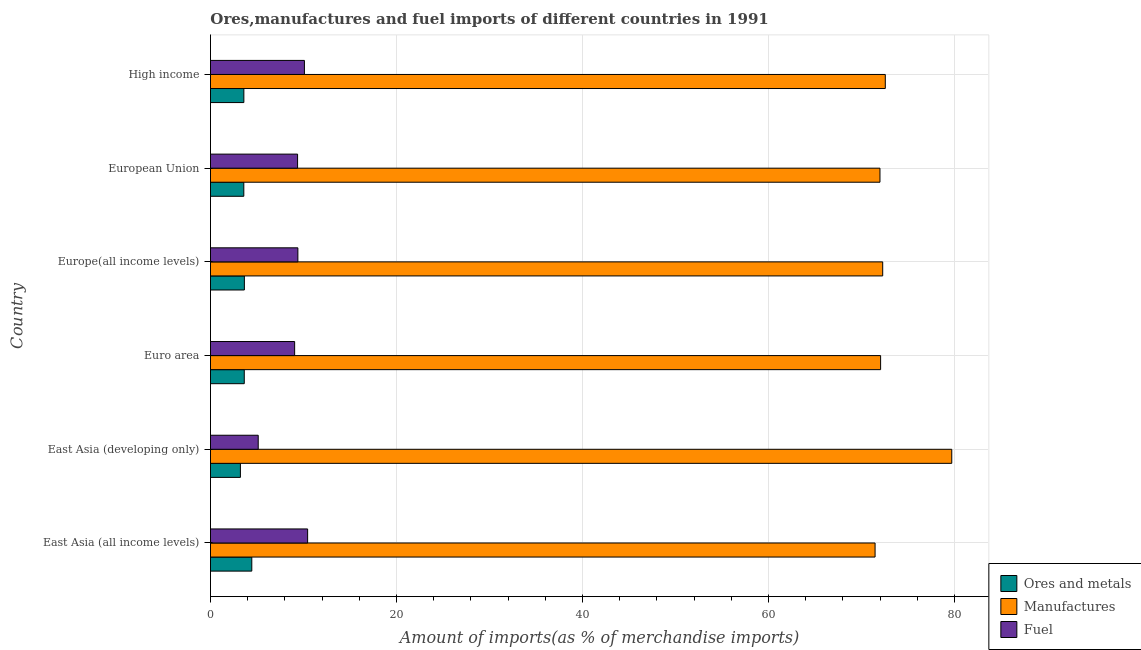How many groups of bars are there?
Your answer should be compact. 6. Are the number of bars per tick equal to the number of legend labels?
Provide a succinct answer. Yes. What is the label of the 1st group of bars from the top?
Give a very brief answer. High income. What is the percentage of manufactures imports in East Asia (developing only)?
Ensure brevity in your answer.  79.71. Across all countries, what is the maximum percentage of ores and metals imports?
Offer a very short reply. 4.44. Across all countries, what is the minimum percentage of fuel imports?
Your answer should be very brief. 5.13. In which country was the percentage of manufactures imports maximum?
Make the answer very short. East Asia (developing only). In which country was the percentage of fuel imports minimum?
Your answer should be very brief. East Asia (developing only). What is the total percentage of manufactures imports in the graph?
Provide a short and direct response. 440.08. What is the difference between the percentage of manufactures imports in Europe(all income levels) and that in High income?
Your response must be concise. -0.28. What is the difference between the percentage of manufactures imports in High income and the percentage of fuel imports in Europe(all income levels)?
Your response must be concise. 63.17. What is the average percentage of ores and metals imports per country?
Ensure brevity in your answer.  3.69. What is the difference between the percentage of ores and metals imports and percentage of manufactures imports in Euro area?
Offer a very short reply. -68.43. What is the ratio of the percentage of ores and metals imports in East Asia (all income levels) to that in Euro area?
Your answer should be compact. 1.22. Is the percentage of manufactures imports in Euro area less than that in European Union?
Offer a terse response. No. What is the difference between the highest and the second highest percentage of ores and metals imports?
Your answer should be compact. 0.8. What is the difference between the highest and the lowest percentage of fuel imports?
Keep it short and to the point. 5.31. In how many countries, is the percentage of ores and metals imports greater than the average percentage of ores and metals imports taken over all countries?
Give a very brief answer. 1. What does the 3rd bar from the top in Euro area represents?
Give a very brief answer. Ores and metals. What does the 2nd bar from the bottom in East Asia (all income levels) represents?
Keep it short and to the point. Manufactures. Is it the case that in every country, the sum of the percentage of ores and metals imports and percentage of manufactures imports is greater than the percentage of fuel imports?
Provide a succinct answer. Yes. How many bars are there?
Make the answer very short. 18. Are all the bars in the graph horizontal?
Provide a short and direct response. Yes. How many countries are there in the graph?
Provide a succinct answer. 6. What is the difference between two consecutive major ticks on the X-axis?
Offer a very short reply. 20. Does the graph contain any zero values?
Give a very brief answer. No. Does the graph contain grids?
Provide a succinct answer. Yes. Where does the legend appear in the graph?
Provide a succinct answer. Bottom right. How are the legend labels stacked?
Offer a very short reply. Vertical. What is the title of the graph?
Your answer should be compact. Ores,manufactures and fuel imports of different countries in 1991. Does "Services" appear as one of the legend labels in the graph?
Make the answer very short. No. What is the label or title of the X-axis?
Your response must be concise. Amount of imports(as % of merchandise imports). What is the label or title of the Y-axis?
Offer a very short reply. Country. What is the Amount of imports(as % of merchandise imports) of Ores and metals in East Asia (all income levels)?
Offer a terse response. 4.44. What is the Amount of imports(as % of merchandise imports) of Manufactures in East Asia (all income levels)?
Provide a short and direct response. 71.47. What is the Amount of imports(as % of merchandise imports) in Fuel in East Asia (all income levels)?
Give a very brief answer. 10.45. What is the Amount of imports(as % of merchandise imports) of Ores and metals in East Asia (developing only)?
Make the answer very short. 3.22. What is the Amount of imports(as % of merchandise imports) in Manufactures in East Asia (developing only)?
Offer a terse response. 79.71. What is the Amount of imports(as % of merchandise imports) in Fuel in East Asia (developing only)?
Make the answer very short. 5.13. What is the Amount of imports(as % of merchandise imports) of Ores and metals in Euro area?
Your answer should be compact. 3.63. What is the Amount of imports(as % of merchandise imports) of Manufactures in Euro area?
Offer a very short reply. 72.06. What is the Amount of imports(as % of merchandise imports) of Fuel in Euro area?
Your response must be concise. 9.05. What is the Amount of imports(as % of merchandise imports) of Ores and metals in Europe(all income levels)?
Give a very brief answer. 3.64. What is the Amount of imports(as % of merchandise imports) in Manufactures in Europe(all income levels)?
Keep it short and to the point. 72.29. What is the Amount of imports(as % of merchandise imports) in Fuel in Europe(all income levels)?
Your answer should be compact. 9.4. What is the Amount of imports(as % of merchandise imports) of Ores and metals in European Union?
Keep it short and to the point. 3.58. What is the Amount of imports(as % of merchandise imports) in Manufactures in European Union?
Ensure brevity in your answer.  71.99. What is the Amount of imports(as % of merchandise imports) in Fuel in European Union?
Your answer should be compact. 9.37. What is the Amount of imports(as % of merchandise imports) in Ores and metals in High income?
Ensure brevity in your answer.  3.59. What is the Amount of imports(as % of merchandise imports) in Manufactures in High income?
Offer a very short reply. 72.57. What is the Amount of imports(as % of merchandise imports) of Fuel in High income?
Ensure brevity in your answer.  10.1. Across all countries, what is the maximum Amount of imports(as % of merchandise imports) in Ores and metals?
Provide a succinct answer. 4.44. Across all countries, what is the maximum Amount of imports(as % of merchandise imports) in Manufactures?
Provide a short and direct response. 79.71. Across all countries, what is the maximum Amount of imports(as % of merchandise imports) of Fuel?
Keep it short and to the point. 10.45. Across all countries, what is the minimum Amount of imports(as % of merchandise imports) of Ores and metals?
Your answer should be very brief. 3.22. Across all countries, what is the minimum Amount of imports(as % of merchandise imports) of Manufactures?
Give a very brief answer. 71.47. Across all countries, what is the minimum Amount of imports(as % of merchandise imports) in Fuel?
Provide a short and direct response. 5.13. What is the total Amount of imports(as % of merchandise imports) in Ores and metals in the graph?
Your answer should be compact. 22.11. What is the total Amount of imports(as % of merchandise imports) in Manufactures in the graph?
Ensure brevity in your answer.  440.08. What is the total Amount of imports(as % of merchandise imports) in Fuel in the graph?
Your answer should be compact. 53.5. What is the difference between the Amount of imports(as % of merchandise imports) in Ores and metals in East Asia (all income levels) and that in East Asia (developing only)?
Give a very brief answer. 1.22. What is the difference between the Amount of imports(as % of merchandise imports) in Manufactures in East Asia (all income levels) and that in East Asia (developing only)?
Your answer should be very brief. -8.25. What is the difference between the Amount of imports(as % of merchandise imports) in Fuel in East Asia (all income levels) and that in East Asia (developing only)?
Ensure brevity in your answer.  5.31. What is the difference between the Amount of imports(as % of merchandise imports) of Ores and metals in East Asia (all income levels) and that in Euro area?
Make the answer very short. 0.81. What is the difference between the Amount of imports(as % of merchandise imports) in Manufactures in East Asia (all income levels) and that in Euro area?
Offer a very short reply. -0.59. What is the difference between the Amount of imports(as % of merchandise imports) in Fuel in East Asia (all income levels) and that in Euro area?
Ensure brevity in your answer.  1.4. What is the difference between the Amount of imports(as % of merchandise imports) of Ores and metals in East Asia (all income levels) and that in Europe(all income levels)?
Make the answer very short. 0.8. What is the difference between the Amount of imports(as % of merchandise imports) in Manufactures in East Asia (all income levels) and that in Europe(all income levels)?
Your answer should be very brief. -0.82. What is the difference between the Amount of imports(as % of merchandise imports) of Fuel in East Asia (all income levels) and that in Europe(all income levels)?
Provide a succinct answer. 1.05. What is the difference between the Amount of imports(as % of merchandise imports) in Ores and metals in East Asia (all income levels) and that in European Union?
Give a very brief answer. 0.86. What is the difference between the Amount of imports(as % of merchandise imports) of Manufactures in East Asia (all income levels) and that in European Union?
Provide a succinct answer. -0.52. What is the difference between the Amount of imports(as % of merchandise imports) of Fuel in East Asia (all income levels) and that in European Union?
Your response must be concise. 1.08. What is the difference between the Amount of imports(as % of merchandise imports) in Ores and metals in East Asia (all income levels) and that in High income?
Give a very brief answer. 0.85. What is the difference between the Amount of imports(as % of merchandise imports) in Manufactures in East Asia (all income levels) and that in High income?
Your answer should be very brief. -1.1. What is the difference between the Amount of imports(as % of merchandise imports) in Fuel in East Asia (all income levels) and that in High income?
Your response must be concise. 0.34. What is the difference between the Amount of imports(as % of merchandise imports) in Ores and metals in East Asia (developing only) and that in Euro area?
Offer a terse response. -0.41. What is the difference between the Amount of imports(as % of merchandise imports) in Manufactures in East Asia (developing only) and that in Euro area?
Provide a succinct answer. 7.65. What is the difference between the Amount of imports(as % of merchandise imports) of Fuel in East Asia (developing only) and that in Euro area?
Make the answer very short. -3.92. What is the difference between the Amount of imports(as % of merchandise imports) in Ores and metals in East Asia (developing only) and that in Europe(all income levels)?
Your answer should be very brief. -0.43. What is the difference between the Amount of imports(as % of merchandise imports) of Manufactures in East Asia (developing only) and that in Europe(all income levels)?
Keep it short and to the point. 7.43. What is the difference between the Amount of imports(as % of merchandise imports) in Fuel in East Asia (developing only) and that in Europe(all income levels)?
Your answer should be very brief. -4.26. What is the difference between the Amount of imports(as % of merchandise imports) in Ores and metals in East Asia (developing only) and that in European Union?
Your answer should be very brief. -0.37. What is the difference between the Amount of imports(as % of merchandise imports) in Manufactures in East Asia (developing only) and that in European Union?
Provide a short and direct response. 7.72. What is the difference between the Amount of imports(as % of merchandise imports) in Fuel in East Asia (developing only) and that in European Union?
Offer a very short reply. -4.23. What is the difference between the Amount of imports(as % of merchandise imports) of Ores and metals in East Asia (developing only) and that in High income?
Offer a terse response. -0.37. What is the difference between the Amount of imports(as % of merchandise imports) of Manufactures in East Asia (developing only) and that in High income?
Ensure brevity in your answer.  7.15. What is the difference between the Amount of imports(as % of merchandise imports) in Fuel in East Asia (developing only) and that in High income?
Keep it short and to the point. -4.97. What is the difference between the Amount of imports(as % of merchandise imports) in Ores and metals in Euro area and that in Europe(all income levels)?
Ensure brevity in your answer.  -0.01. What is the difference between the Amount of imports(as % of merchandise imports) of Manufactures in Euro area and that in Europe(all income levels)?
Keep it short and to the point. -0.22. What is the difference between the Amount of imports(as % of merchandise imports) of Fuel in Euro area and that in Europe(all income levels)?
Ensure brevity in your answer.  -0.35. What is the difference between the Amount of imports(as % of merchandise imports) of Ores and metals in Euro area and that in European Union?
Your response must be concise. 0.05. What is the difference between the Amount of imports(as % of merchandise imports) in Manufactures in Euro area and that in European Union?
Your response must be concise. 0.07. What is the difference between the Amount of imports(as % of merchandise imports) of Fuel in Euro area and that in European Union?
Your answer should be compact. -0.32. What is the difference between the Amount of imports(as % of merchandise imports) of Ores and metals in Euro area and that in High income?
Ensure brevity in your answer.  0.04. What is the difference between the Amount of imports(as % of merchandise imports) of Manufactures in Euro area and that in High income?
Offer a very short reply. -0.5. What is the difference between the Amount of imports(as % of merchandise imports) in Fuel in Euro area and that in High income?
Make the answer very short. -1.05. What is the difference between the Amount of imports(as % of merchandise imports) in Ores and metals in Europe(all income levels) and that in European Union?
Ensure brevity in your answer.  0.06. What is the difference between the Amount of imports(as % of merchandise imports) in Manufactures in Europe(all income levels) and that in European Union?
Ensure brevity in your answer.  0.29. What is the difference between the Amount of imports(as % of merchandise imports) of Fuel in Europe(all income levels) and that in European Union?
Give a very brief answer. 0.03. What is the difference between the Amount of imports(as % of merchandise imports) of Ores and metals in Europe(all income levels) and that in High income?
Your answer should be compact. 0.06. What is the difference between the Amount of imports(as % of merchandise imports) in Manufactures in Europe(all income levels) and that in High income?
Provide a short and direct response. -0.28. What is the difference between the Amount of imports(as % of merchandise imports) of Fuel in Europe(all income levels) and that in High income?
Ensure brevity in your answer.  -0.7. What is the difference between the Amount of imports(as % of merchandise imports) of Ores and metals in European Union and that in High income?
Keep it short and to the point. -0.01. What is the difference between the Amount of imports(as % of merchandise imports) in Manufactures in European Union and that in High income?
Provide a succinct answer. -0.57. What is the difference between the Amount of imports(as % of merchandise imports) of Fuel in European Union and that in High income?
Provide a succinct answer. -0.74. What is the difference between the Amount of imports(as % of merchandise imports) of Ores and metals in East Asia (all income levels) and the Amount of imports(as % of merchandise imports) of Manufactures in East Asia (developing only)?
Ensure brevity in your answer.  -75.27. What is the difference between the Amount of imports(as % of merchandise imports) of Ores and metals in East Asia (all income levels) and the Amount of imports(as % of merchandise imports) of Fuel in East Asia (developing only)?
Ensure brevity in your answer.  -0.69. What is the difference between the Amount of imports(as % of merchandise imports) in Manufactures in East Asia (all income levels) and the Amount of imports(as % of merchandise imports) in Fuel in East Asia (developing only)?
Provide a short and direct response. 66.33. What is the difference between the Amount of imports(as % of merchandise imports) of Ores and metals in East Asia (all income levels) and the Amount of imports(as % of merchandise imports) of Manufactures in Euro area?
Offer a very short reply. -67.62. What is the difference between the Amount of imports(as % of merchandise imports) in Ores and metals in East Asia (all income levels) and the Amount of imports(as % of merchandise imports) in Fuel in Euro area?
Provide a short and direct response. -4.61. What is the difference between the Amount of imports(as % of merchandise imports) in Manufactures in East Asia (all income levels) and the Amount of imports(as % of merchandise imports) in Fuel in Euro area?
Your answer should be very brief. 62.42. What is the difference between the Amount of imports(as % of merchandise imports) of Ores and metals in East Asia (all income levels) and the Amount of imports(as % of merchandise imports) of Manufactures in Europe(all income levels)?
Provide a short and direct response. -67.84. What is the difference between the Amount of imports(as % of merchandise imports) of Ores and metals in East Asia (all income levels) and the Amount of imports(as % of merchandise imports) of Fuel in Europe(all income levels)?
Provide a short and direct response. -4.96. What is the difference between the Amount of imports(as % of merchandise imports) in Manufactures in East Asia (all income levels) and the Amount of imports(as % of merchandise imports) in Fuel in Europe(all income levels)?
Offer a terse response. 62.07. What is the difference between the Amount of imports(as % of merchandise imports) in Ores and metals in East Asia (all income levels) and the Amount of imports(as % of merchandise imports) in Manufactures in European Union?
Provide a short and direct response. -67.55. What is the difference between the Amount of imports(as % of merchandise imports) in Ores and metals in East Asia (all income levels) and the Amount of imports(as % of merchandise imports) in Fuel in European Union?
Your answer should be compact. -4.92. What is the difference between the Amount of imports(as % of merchandise imports) in Manufactures in East Asia (all income levels) and the Amount of imports(as % of merchandise imports) in Fuel in European Union?
Your response must be concise. 62.1. What is the difference between the Amount of imports(as % of merchandise imports) of Ores and metals in East Asia (all income levels) and the Amount of imports(as % of merchandise imports) of Manufactures in High income?
Make the answer very short. -68.12. What is the difference between the Amount of imports(as % of merchandise imports) of Ores and metals in East Asia (all income levels) and the Amount of imports(as % of merchandise imports) of Fuel in High income?
Keep it short and to the point. -5.66. What is the difference between the Amount of imports(as % of merchandise imports) of Manufactures in East Asia (all income levels) and the Amount of imports(as % of merchandise imports) of Fuel in High income?
Provide a succinct answer. 61.36. What is the difference between the Amount of imports(as % of merchandise imports) in Ores and metals in East Asia (developing only) and the Amount of imports(as % of merchandise imports) in Manufactures in Euro area?
Ensure brevity in your answer.  -68.84. What is the difference between the Amount of imports(as % of merchandise imports) in Ores and metals in East Asia (developing only) and the Amount of imports(as % of merchandise imports) in Fuel in Euro area?
Ensure brevity in your answer.  -5.83. What is the difference between the Amount of imports(as % of merchandise imports) in Manufactures in East Asia (developing only) and the Amount of imports(as % of merchandise imports) in Fuel in Euro area?
Keep it short and to the point. 70.66. What is the difference between the Amount of imports(as % of merchandise imports) of Ores and metals in East Asia (developing only) and the Amount of imports(as % of merchandise imports) of Manufactures in Europe(all income levels)?
Keep it short and to the point. -69.07. What is the difference between the Amount of imports(as % of merchandise imports) in Ores and metals in East Asia (developing only) and the Amount of imports(as % of merchandise imports) in Fuel in Europe(all income levels)?
Provide a short and direct response. -6.18. What is the difference between the Amount of imports(as % of merchandise imports) of Manufactures in East Asia (developing only) and the Amount of imports(as % of merchandise imports) of Fuel in Europe(all income levels)?
Keep it short and to the point. 70.31. What is the difference between the Amount of imports(as % of merchandise imports) of Ores and metals in East Asia (developing only) and the Amount of imports(as % of merchandise imports) of Manufactures in European Union?
Offer a very short reply. -68.77. What is the difference between the Amount of imports(as % of merchandise imports) of Ores and metals in East Asia (developing only) and the Amount of imports(as % of merchandise imports) of Fuel in European Union?
Provide a succinct answer. -6.15. What is the difference between the Amount of imports(as % of merchandise imports) in Manufactures in East Asia (developing only) and the Amount of imports(as % of merchandise imports) in Fuel in European Union?
Ensure brevity in your answer.  70.35. What is the difference between the Amount of imports(as % of merchandise imports) of Ores and metals in East Asia (developing only) and the Amount of imports(as % of merchandise imports) of Manufactures in High income?
Your answer should be very brief. -69.35. What is the difference between the Amount of imports(as % of merchandise imports) of Ores and metals in East Asia (developing only) and the Amount of imports(as % of merchandise imports) of Fuel in High income?
Your answer should be very brief. -6.88. What is the difference between the Amount of imports(as % of merchandise imports) in Manufactures in East Asia (developing only) and the Amount of imports(as % of merchandise imports) in Fuel in High income?
Make the answer very short. 69.61. What is the difference between the Amount of imports(as % of merchandise imports) of Ores and metals in Euro area and the Amount of imports(as % of merchandise imports) of Manufactures in Europe(all income levels)?
Make the answer very short. -68.65. What is the difference between the Amount of imports(as % of merchandise imports) in Ores and metals in Euro area and the Amount of imports(as % of merchandise imports) in Fuel in Europe(all income levels)?
Provide a short and direct response. -5.77. What is the difference between the Amount of imports(as % of merchandise imports) of Manufactures in Euro area and the Amount of imports(as % of merchandise imports) of Fuel in Europe(all income levels)?
Your answer should be very brief. 62.66. What is the difference between the Amount of imports(as % of merchandise imports) in Ores and metals in Euro area and the Amount of imports(as % of merchandise imports) in Manufactures in European Union?
Keep it short and to the point. -68.36. What is the difference between the Amount of imports(as % of merchandise imports) in Ores and metals in Euro area and the Amount of imports(as % of merchandise imports) in Fuel in European Union?
Make the answer very short. -5.73. What is the difference between the Amount of imports(as % of merchandise imports) of Manufactures in Euro area and the Amount of imports(as % of merchandise imports) of Fuel in European Union?
Give a very brief answer. 62.69. What is the difference between the Amount of imports(as % of merchandise imports) of Ores and metals in Euro area and the Amount of imports(as % of merchandise imports) of Manufactures in High income?
Offer a very short reply. -68.93. What is the difference between the Amount of imports(as % of merchandise imports) of Ores and metals in Euro area and the Amount of imports(as % of merchandise imports) of Fuel in High income?
Keep it short and to the point. -6.47. What is the difference between the Amount of imports(as % of merchandise imports) in Manufactures in Euro area and the Amount of imports(as % of merchandise imports) in Fuel in High income?
Offer a terse response. 61.96. What is the difference between the Amount of imports(as % of merchandise imports) of Ores and metals in Europe(all income levels) and the Amount of imports(as % of merchandise imports) of Manufactures in European Union?
Your response must be concise. -68.35. What is the difference between the Amount of imports(as % of merchandise imports) of Ores and metals in Europe(all income levels) and the Amount of imports(as % of merchandise imports) of Fuel in European Union?
Offer a very short reply. -5.72. What is the difference between the Amount of imports(as % of merchandise imports) in Manufactures in Europe(all income levels) and the Amount of imports(as % of merchandise imports) in Fuel in European Union?
Your answer should be very brief. 62.92. What is the difference between the Amount of imports(as % of merchandise imports) in Ores and metals in Europe(all income levels) and the Amount of imports(as % of merchandise imports) in Manufactures in High income?
Provide a succinct answer. -68.92. What is the difference between the Amount of imports(as % of merchandise imports) of Ores and metals in Europe(all income levels) and the Amount of imports(as % of merchandise imports) of Fuel in High income?
Keep it short and to the point. -6.46. What is the difference between the Amount of imports(as % of merchandise imports) of Manufactures in Europe(all income levels) and the Amount of imports(as % of merchandise imports) of Fuel in High income?
Offer a very short reply. 62.18. What is the difference between the Amount of imports(as % of merchandise imports) in Ores and metals in European Union and the Amount of imports(as % of merchandise imports) in Manufactures in High income?
Give a very brief answer. -68.98. What is the difference between the Amount of imports(as % of merchandise imports) in Ores and metals in European Union and the Amount of imports(as % of merchandise imports) in Fuel in High income?
Offer a terse response. -6.52. What is the difference between the Amount of imports(as % of merchandise imports) of Manufactures in European Union and the Amount of imports(as % of merchandise imports) of Fuel in High income?
Provide a short and direct response. 61.89. What is the average Amount of imports(as % of merchandise imports) of Ores and metals per country?
Give a very brief answer. 3.69. What is the average Amount of imports(as % of merchandise imports) in Manufactures per country?
Ensure brevity in your answer.  73.35. What is the average Amount of imports(as % of merchandise imports) in Fuel per country?
Keep it short and to the point. 8.92. What is the difference between the Amount of imports(as % of merchandise imports) of Ores and metals and Amount of imports(as % of merchandise imports) of Manufactures in East Asia (all income levels)?
Offer a very short reply. -67.02. What is the difference between the Amount of imports(as % of merchandise imports) in Ores and metals and Amount of imports(as % of merchandise imports) in Fuel in East Asia (all income levels)?
Make the answer very short. -6. What is the difference between the Amount of imports(as % of merchandise imports) in Manufactures and Amount of imports(as % of merchandise imports) in Fuel in East Asia (all income levels)?
Provide a short and direct response. 61.02. What is the difference between the Amount of imports(as % of merchandise imports) in Ores and metals and Amount of imports(as % of merchandise imports) in Manufactures in East Asia (developing only)?
Your answer should be very brief. -76.49. What is the difference between the Amount of imports(as % of merchandise imports) of Ores and metals and Amount of imports(as % of merchandise imports) of Fuel in East Asia (developing only)?
Your answer should be very brief. -1.92. What is the difference between the Amount of imports(as % of merchandise imports) in Manufactures and Amount of imports(as % of merchandise imports) in Fuel in East Asia (developing only)?
Offer a terse response. 74.58. What is the difference between the Amount of imports(as % of merchandise imports) in Ores and metals and Amount of imports(as % of merchandise imports) in Manufactures in Euro area?
Make the answer very short. -68.43. What is the difference between the Amount of imports(as % of merchandise imports) in Ores and metals and Amount of imports(as % of merchandise imports) in Fuel in Euro area?
Your answer should be compact. -5.42. What is the difference between the Amount of imports(as % of merchandise imports) of Manufactures and Amount of imports(as % of merchandise imports) of Fuel in Euro area?
Offer a very short reply. 63.01. What is the difference between the Amount of imports(as % of merchandise imports) in Ores and metals and Amount of imports(as % of merchandise imports) in Manufactures in Europe(all income levels)?
Your response must be concise. -68.64. What is the difference between the Amount of imports(as % of merchandise imports) of Ores and metals and Amount of imports(as % of merchandise imports) of Fuel in Europe(all income levels)?
Provide a short and direct response. -5.75. What is the difference between the Amount of imports(as % of merchandise imports) of Manufactures and Amount of imports(as % of merchandise imports) of Fuel in Europe(all income levels)?
Keep it short and to the point. 62.89. What is the difference between the Amount of imports(as % of merchandise imports) in Ores and metals and Amount of imports(as % of merchandise imports) in Manufactures in European Union?
Provide a short and direct response. -68.41. What is the difference between the Amount of imports(as % of merchandise imports) in Ores and metals and Amount of imports(as % of merchandise imports) in Fuel in European Union?
Offer a very short reply. -5.78. What is the difference between the Amount of imports(as % of merchandise imports) of Manufactures and Amount of imports(as % of merchandise imports) of Fuel in European Union?
Offer a very short reply. 62.62. What is the difference between the Amount of imports(as % of merchandise imports) of Ores and metals and Amount of imports(as % of merchandise imports) of Manufactures in High income?
Your answer should be very brief. -68.98. What is the difference between the Amount of imports(as % of merchandise imports) in Ores and metals and Amount of imports(as % of merchandise imports) in Fuel in High income?
Keep it short and to the point. -6.51. What is the difference between the Amount of imports(as % of merchandise imports) in Manufactures and Amount of imports(as % of merchandise imports) in Fuel in High income?
Offer a terse response. 62.46. What is the ratio of the Amount of imports(as % of merchandise imports) of Ores and metals in East Asia (all income levels) to that in East Asia (developing only)?
Your answer should be very brief. 1.38. What is the ratio of the Amount of imports(as % of merchandise imports) of Manufactures in East Asia (all income levels) to that in East Asia (developing only)?
Give a very brief answer. 0.9. What is the ratio of the Amount of imports(as % of merchandise imports) in Fuel in East Asia (all income levels) to that in East Asia (developing only)?
Offer a terse response. 2.03. What is the ratio of the Amount of imports(as % of merchandise imports) in Ores and metals in East Asia (all income levels) to that in Euro area?
Give a very brief answer. 1.22. What is the ratio of the Amount of imports(as % of merchandise imports) in Manufactures in East Asia (all income levels) to that in Euro area?
Give a very brief answer. 0.99. What is the ratio of the Amount of imports(as % of merchandise imports) in Fuel in East Asia (all income levels) to that in Euro area?
Offer a terse response. 1.15. What is the ratio of the Amount of imports(as % of merchandise imports) in Ores and metals in East Asia (all income levels) to that in Europe(all income levels)?
Your response must be concise. 1.22. What is the ratio of the Amount of imports(as % of merchandise imports) of Manufactures in East Asia (all income levels) to that in Europe(all income levels)?
Your answer should be compact. 0.99. What is the ratio of the Amount of imports(as % of merchandise imports) in Fuel in East Asia (all income levels) to that in Europe(all income levels)?
Offer a very short reply. 1.11. What is the ratio of the Amount of imports(as % of merchandise imports) in Ores and metals in East Asia (all income levels) to that in European Union?
Your answer should be compact. 1.24. What is the ratio of the Amount of imports(as % of merchandise imports) of Manufactures in East Asia (all income levels) to that in European Union?
Ensure brevity in your answer.  0.99. What is the ratio of the Amount of imports(as % of merchandise imports) of Fuel in East Asia (all income levels) to that in European Union?
Your answer should be very brief. 1.12. What is the ratio of the Amount of imports(as % of merchandise imports) in Ores and metals in East Asia (all income levels) to that in High income?
Offer a terse response. 1.24. What is the ratio of the Amount of imports(as % of merchandise imports) in Manufactures in East Asia (all income levels) to that in High income?
Your answer should be very brief. 0.98. What is the ratio of the Amount of imports(as % of merchandise imports) of Fuel in East Asia (all income levels) to that in High income?
Make the answer very short. 1.03. What is the ratio of the Amount of imports(as % of merchandise imports) of Ores and metals in East Asia (developing only) to that in Euro area?
Provide a short and direct response. 0.89. What is the ratio of the Amount of imports(as % of merchandise imports) in Manufactures in East Asia (developing only) to that in Euro area?
Ensure brevity in your answer.  1.11. What is the ratio of the Amount of imports(as % of merchandise imports) in Fuel in East Asia (developing only) to that in Euro area?
Provide a short and direct response. 0.57. What is the ratio of the Amount of imports(as % of merchandise imports) of Ores and metals in East Asia (developing only) to that in Europe(all income levels)?
Your answer should be very brief. 0.88. What is the ratio of the Amount of imports(as % of merchandise imports) in Manufactures in East Asia (developing only) to that in Europe(all income levels)?
Provide a succinct answer. 1.1. What is the ratio of the Amount of imports(as % of merchandise imports) of Fuel in East Asia (developing only) to that in Europe(all income levels)?
Your answer should be compact. 0.55. What is the ratio of the Amount of imports(as % of merchandise imports) of Ores and metals in East Asia (developing only) to that in European Union?
Offer a terse response. 0.9. What is the ratio of the Amount of imports(as % of merchandise imports) in Manufactures in East Asia (developing only) to that in European Union?
Your answer should be compact. 1.11. What is the ratio of the Amount of imports(as % of merchandise imports) in Fuel in East Asia (developing only) to that in European Union?
Your response must be concise. 0.55. What is the ratio of the Amount of imports(as % of merchandise imports) of Ores and metals in East Asia (developing only) to that in High income?
Give a very brief answer. 0.9. What is the ratio of the Amount of imports(as % of merchandise imports) in Manufactures in East Asia (developing only) to that in High income?
Offer a very short reply. 1.1. What is the ratio of the Amount of imports(as % of merchandise imports) in Fuel in East Asia (developing only) to that in High income?
Offer a very short reply. 0.51. What is the ratio of the Amount of imports(as % of merchandise imports) of Ores and metals in Euro area to that in Europe(all income levels)?
Provide a short and direct response. 1. What is the ratio of the Amount of imports(as % of merchandise imports) of Manufactures in Euro area to that in Europe(all income levels)?
Your answer should be compact. 1. What is the ratio of the Amount of imports(as % of merchandise imports) in Fuel in Euro area to that in Europe(all income levels)?
Give a very brief answer. 0.96. What is the ratio of the Amount of imports(as % of merchandise imports) in Ores and metals in Euro area to that in European Union?
Your answer should be very brief. 1.01. What is the ratio of the Amount of imports(as % of merchandise imports) in Fuel in Euro area to that in European Union?
Keep it short and to the point. 0.97. What is the ratio of the Amount of imports(as % of merchandise imports) of Ores and metals in Euro area to that in High income?
Your answer should be compact. 1.01. What is the ratio of the Amount of imports(as % of merchandise imports) of Manufactures in Euro area to that in High income?
Keep it short and to the point. 0.99. What is the ratio of the Amount of imports(as % of merchandise imports) in Fuel in Euro area to that in High income?
Your answer should be very brief. 0.9. What is the ratio of the Amount of imports(as % of merchandise imports) in Ores and metals in Europe(all income levels) to that in European Union?
Your answer should be very brief. 1.02. What is the ratio of the Amount of imports(as % of merchandise imports) of Ores and metals in Europe(all income levels) to that in High income?
Offer a very short reply. 1.02. What is the ratio of the Amount of imports(as % of merchandise imports) of Manufactures in Europe(all income levels) to that in High income?
Offer a terse response. 1. What is the ratio of the Amount of imports(as % of merchandise imports) of Fuel in Europe(all income levels) to that in High income?
Make the answer very short. 0.93. What is the ratio of the Amount of imports(as % of merchandise imports) of Ores and metals in European Union to that in High income?
Your response must be concise. 1. What is the ratio of the Amount of imports(as % of merchandise imports) of Manufactures in European Union to that in High income?
Your response must be concise. 0.99. What is the ratio of the Amount of imports(as % of merchandise imports) of Fuel in European Union to that in High income?
Make the answer very short. 0.93. What is the difference between the highest and the second highest Amount of imports(as % of merchandise imports) of Ores and metals?
Give a very brief answer. 0.8. What is the difference between the highest and the second highest Amount of imports(as % of merchandise imports) of Manufactures?
Make the answer very short. 7.15. What is the difference between the highest and the second highest Amount of imports(as % of merchandise imports) of Fuel?
Offer a terse response. 0.34. What is the difference between the highest and the lowest Amount of imports(as % of merchandise imports) in Ores and metals?
Provide a succinct answer. 1.22. What is the difference between the highest and the lowest Amount of imports(as % of merchandise imports) in Manufactures?
Make the answer very short. 8.25. What is the difference between the highest and the lowest Amount of imports(as % of merchandise imports) of Fuel?
Ensure brevity in your answer.  5.31. 